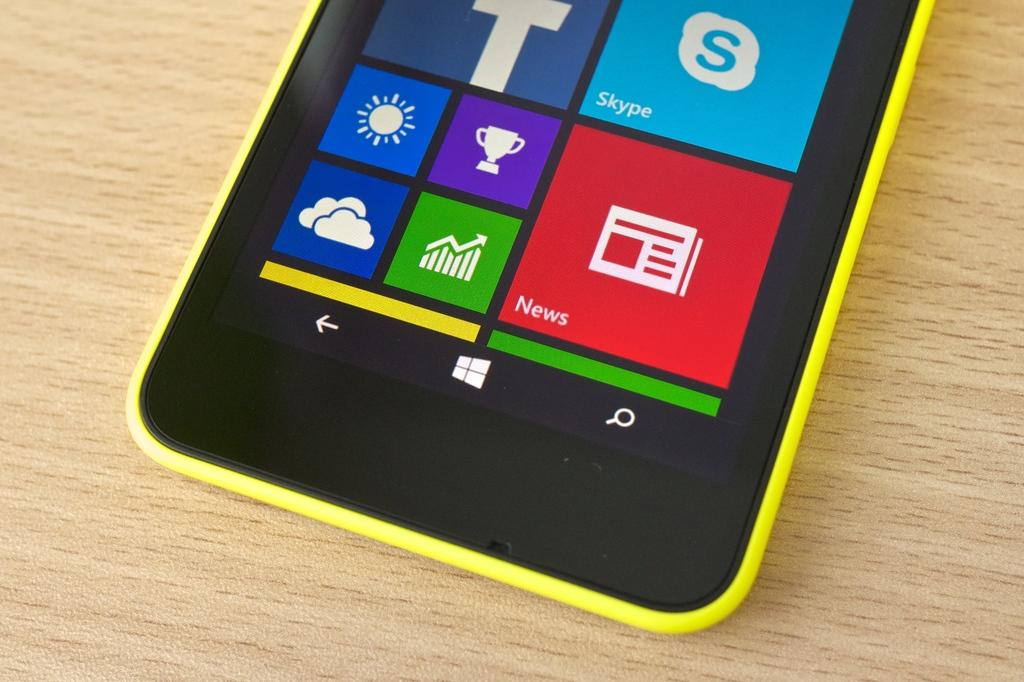<image>
Write a terse but informative summary of the picture. a phone with the word news shown on it 